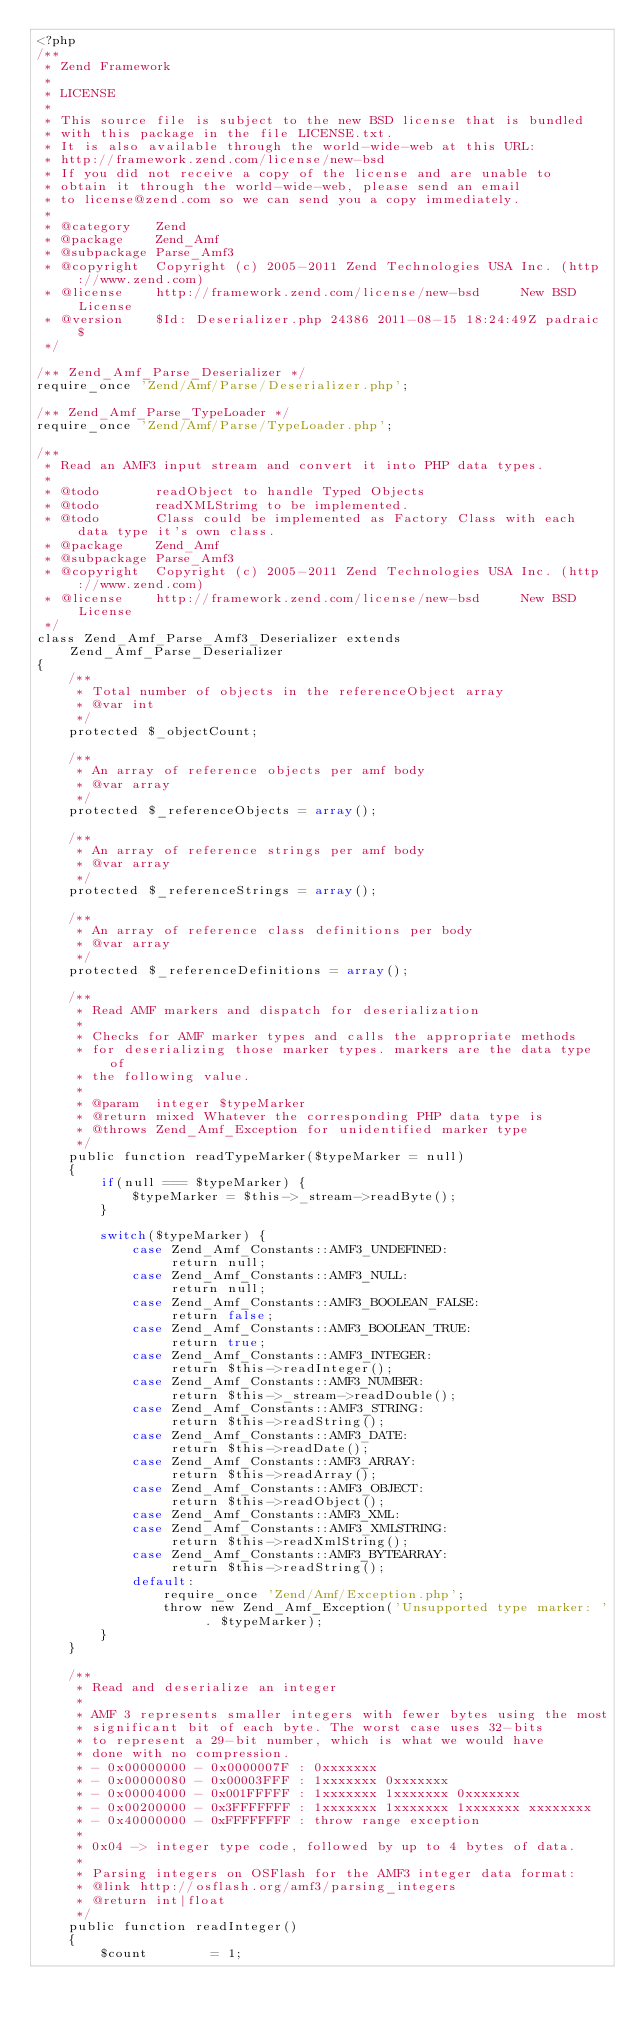<code> <loc_0><loc_0><loc_500><loc_500><_PHP_><?php
/**
 * Zend Framework
 *
 * LICENSE
 *
 * This source file is subject to the new BSD license that is bundled
 * with this package in the file LICENSE.txt.
 * It is also available through the world-wide-web at this URL:
 * http://framework.zend.com/license/new-bsd
 * If you did not receive a copy of the license and are unable to
 * obtain it through the world-wide-web, please send an email
 * to license@zend.com so we can send you a copy immediately.
 *
 * @category   Zend
 * @package    Zend_Amf
 * @subpackage Parse_Amf3
 * @copyright  Copyright (c) 2005-2011 Zend Technologies USA Inc. (http://www.zend.com)
 * @license    http://framework.zend.com/license/new-bsd     New BSD License
 * @version    $Id: Deserializer.php 24386 2011-08-15 18:24:49Z padraic $
 */

/** Zend_Amf_Parse_Deserializer */
require_once 'Zend/Amf/Parse/Deserializer.php';

/** Zend_Amf_Parse_TypeLoader */
require_once 'Zend/Amf/Parse/TypeLoader.php';

/**
 * Read an AMF3 input stream and convert it into PHP data types.
 *
 * @todo       readObject to handle Typed Objects
 * @todo       readXMLStrimg to be implemented.
 * @todo       Class could be implemented as Factory Class with each data type it's own class.
 * @package    Zend_Amf
 * @subpackage Parse_Amf3
 * @copyright  Copyright (c) 2005-2011 Zend Technologies USA Inc. (http://www.zend.com)
 * @license    http://framework.zend.com/license/new-bsd     New BSD License
 */
class Zend_Amf_Parse_Amf3_Deserializer extends Zend_Amf_Parse_Deserializer
{
    /**
     * Total number of objects in the referenceObject array
     * @var int
     */
    protected $_objectCount;

    /**
     * An array of reference objects per amf body
     * @var array
     */
    protected $_referenceObjects = array();

    /**
     * An array of reference strings per amf body
     * @var array
     */
    protected $_referenceStrings = array();

    /**
     * An array of reference class definitions per body
     * @var array
     */
    protected $_referenceDefinitions = array();

    /**
     * Read AMF markers and dispatch for deserialization
     *
     * Checks for AMF marker types and calls the appropriate methods
     * for deserializing those marker types. markers are the data type of
     * the following value.
     *
     * @param  integer $typeMarker
     * @return mixed Whatever the corresponding PHP data type is
     * @throws Zend_Amf_Exception for unidentified marker type
     */
    public function readTypeMarker($typeMarker = null)
    {
        if(null === $typeMarker) {
            $typeMarker = $this->_stream->readByte();
        }

        switch($typeMarker) {
            case Zend_Amf_Constants::AMF3_UNDEFINED:
                 return null;
            case Zend_Amf_Constants::AMF3_NULL:
                 return null;
            case Zend_Amf_Constants::AMF3_BOOLEAN_FALSE:
                 return false;
            case Zend_Amf_Constants::AMF3_BOOLEAN_TRUE:
                 return true;
            case Zend_Amf_Constants::AMF3_INTEGER:
                 return $this->readInteger();
            case Zend_Amf_Constants::AMF3_NUMBER:
                 return $this->_stream->readDouble();
            case Zend_Amf_Constants::AMF3_STRING:
                 return $this->readString();
            case Zend_Amf_Constants::AMF3_DATE:
                 return $this->readDate();
            case Zend_Amf_Constants::AMF3_ARRAY:
                 return $this->readArray();
            case Zend_Amf_Constants::AMF3_OBJECT:
                 return $this->readObject();
            case Zend_Amf_Constants::AMF3_XML:
            case Zend_Amf_Constants::AMF3_XMLSTRING:
                 return $this->readXmlString();
            case Zend_Amf_Constants::AMF3_BYTEARRAY:
                 return $this->readString();
            default:
                require_once 'Zend/Amf/Exception.php';
                throw new Zend_Amf_Exception('Unsupported type marker: ' . $typeMarker);
        }
    }

    /**
     * Read and deserialize an integer
     *
     * AMF 3 represents smaller integers with fewer bytes using the most
     * significant bit of each byte. The worst case uses 32-bits
     * to represent a 29-bit number, which is what we would have
     * done with no compression.
     * - 0x00000000 - 0x0000007F : 0xxxxxxx
     * - 0x00000080 - 0x00003FFF : 1xxxxxxx 0xxxxxxx
     * - 0x00004000 - 0x001FFFFF : 1xxxxxxx 1xxxxxxx 0xxxxxxx
     * - 0x00200000 - 0x3FFFFFFF : 1xxxxxxx 1xxxxxxx 1xxxxxxx xxxxxxxx
     * - 0x40000000 - 0xFFFFFFFF : throw range exception
     *
     * 0x04 -> integer type code, followed by up to 4 bytes of data.
     *
     * Parsing integers on OSFlash for the AMF3 integer data format:
     * @link http://osflash.org/amf3/parsing_integers
     * @return int|float
     */
    public function readInteger()
    {
        $count        = 1;</code> 